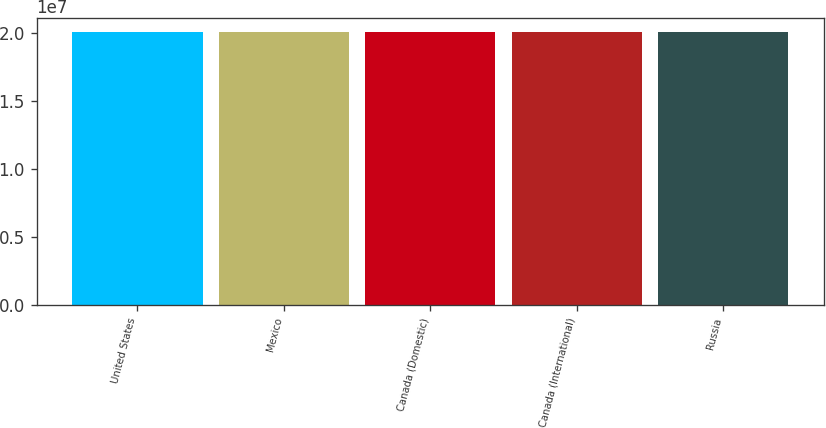Convert chart. <chart><loc_0><loc_0><loc_500><loc_500><bar_chart><fcel>United States<fcel>Mexico<fcel>Canada (Domestic)<fcel>Canada (International)<fcel>Russia<nl><fcel>2.0122e+07<fcel>2.0142e+07<fcel>2.0132e+07<fcel>2.0102e+07<fcel>2.0126e+07<nl></chart> 